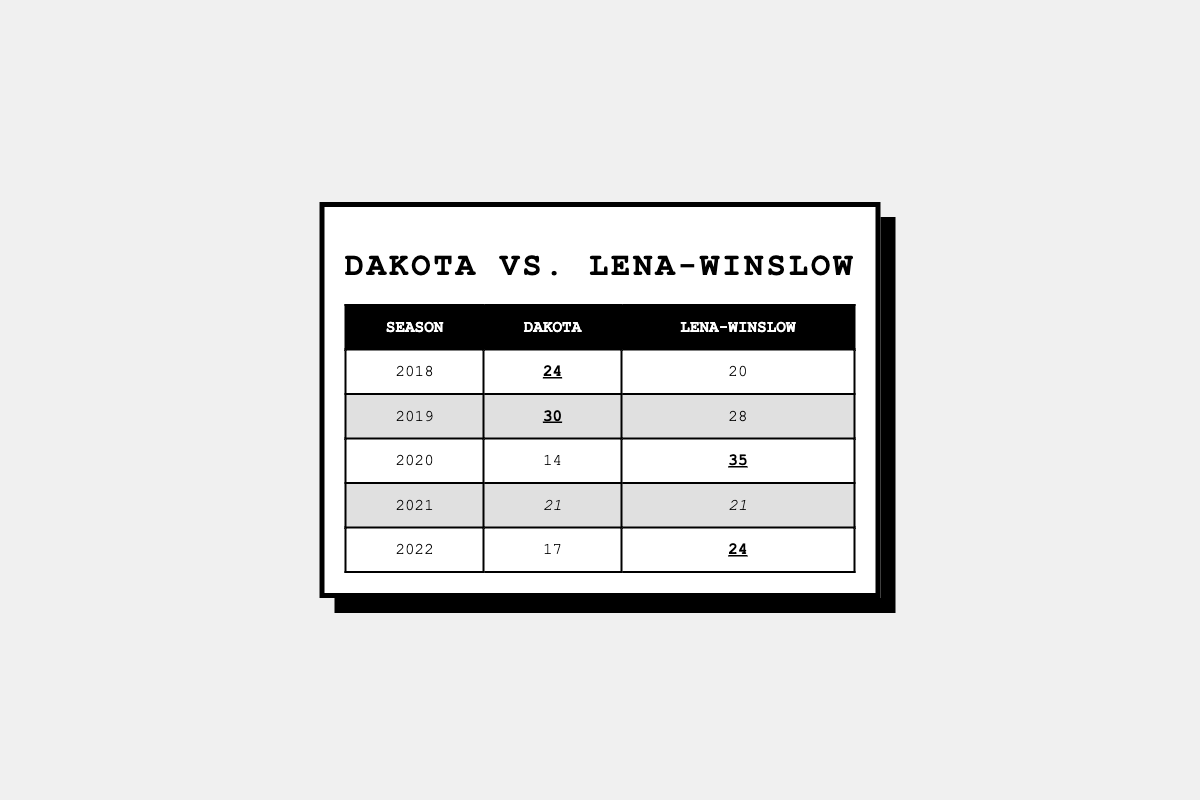What was Dakota's highest score against Lena-Winslow in the last five seasons? Reviewing the table, Dakota's scores are 24, 30, 14, 21, and 17. The highest score among these is 30 in 2019.
Answer: 30 In which season did Dakota score the lowest? The scores for Dakota are 24 (2018), 30 (2019), 14 (2020), 21 (2021), and 17 (2022). The lowest score is 14 in 2020.
Answer: 2020 How many times did Dakota win against Lena-Winslow in the last five seasons? Dakota won in 2018 and 2019. Checking each season: 2018 (24 vs 20), 2019 (30 vs 28), and in 2020, Lena-Winslow won (14 vs 35). 2021 was a tie (21 vs 21), and in 2022, Lena-Winslow won (17 vs 24). Therefore, Dakota won twice.
Answer: 2 What was the score difference in Dakota's lowest-scoring game against Lena-Winslow? Dakota's lowest score was 14 in 2020 while Lena-Winslow scored 35, leading to a difference of 35 - 14 = 21 points.
Answer: 21 What is the average score of Dakota over the last five seasons? Dakota's scores are 24, 30, 14, 21, and 17. The sum is 24 + 30 + 14 + 21 + 17 = 106. The average score is 106 divided by 5, which equals 21.2.
Answer: 21.2 In how many seasons did both teams score at least 20 points? Looking at the table, Dakota scored at least 20 in 2018, 2019, 2021, and 2022. Lena-Winslow scored at least 20 in 2018, 2019, and 2022. Counting both teams, in 2018, 2019, and 2021, Dakota scored at least 20 but not 2020 and only 2022 for Lena-Winslow; hence 4 occasions for Dakota and 3 for Lena-Winslow but counted jointly only 3 distinct occasions.
Answer: 3 Which season had the highest combined score from both teams? The combined scores for each season are: 2018: 24 + 20 = 44, 2019: 30 + 28 = 58, 2020: 14 + 35 = 49, 2021: 21 + 21 = 42, 2022: 17 + 24 = 41. The highest combined score is 58 in 2019.
Answer: 2019 Was there a tie in the scores, and if so, which season? Checking the scores, the only tie is in 2021 where both teams scored 21 points.
Answer: Yes, 2021 